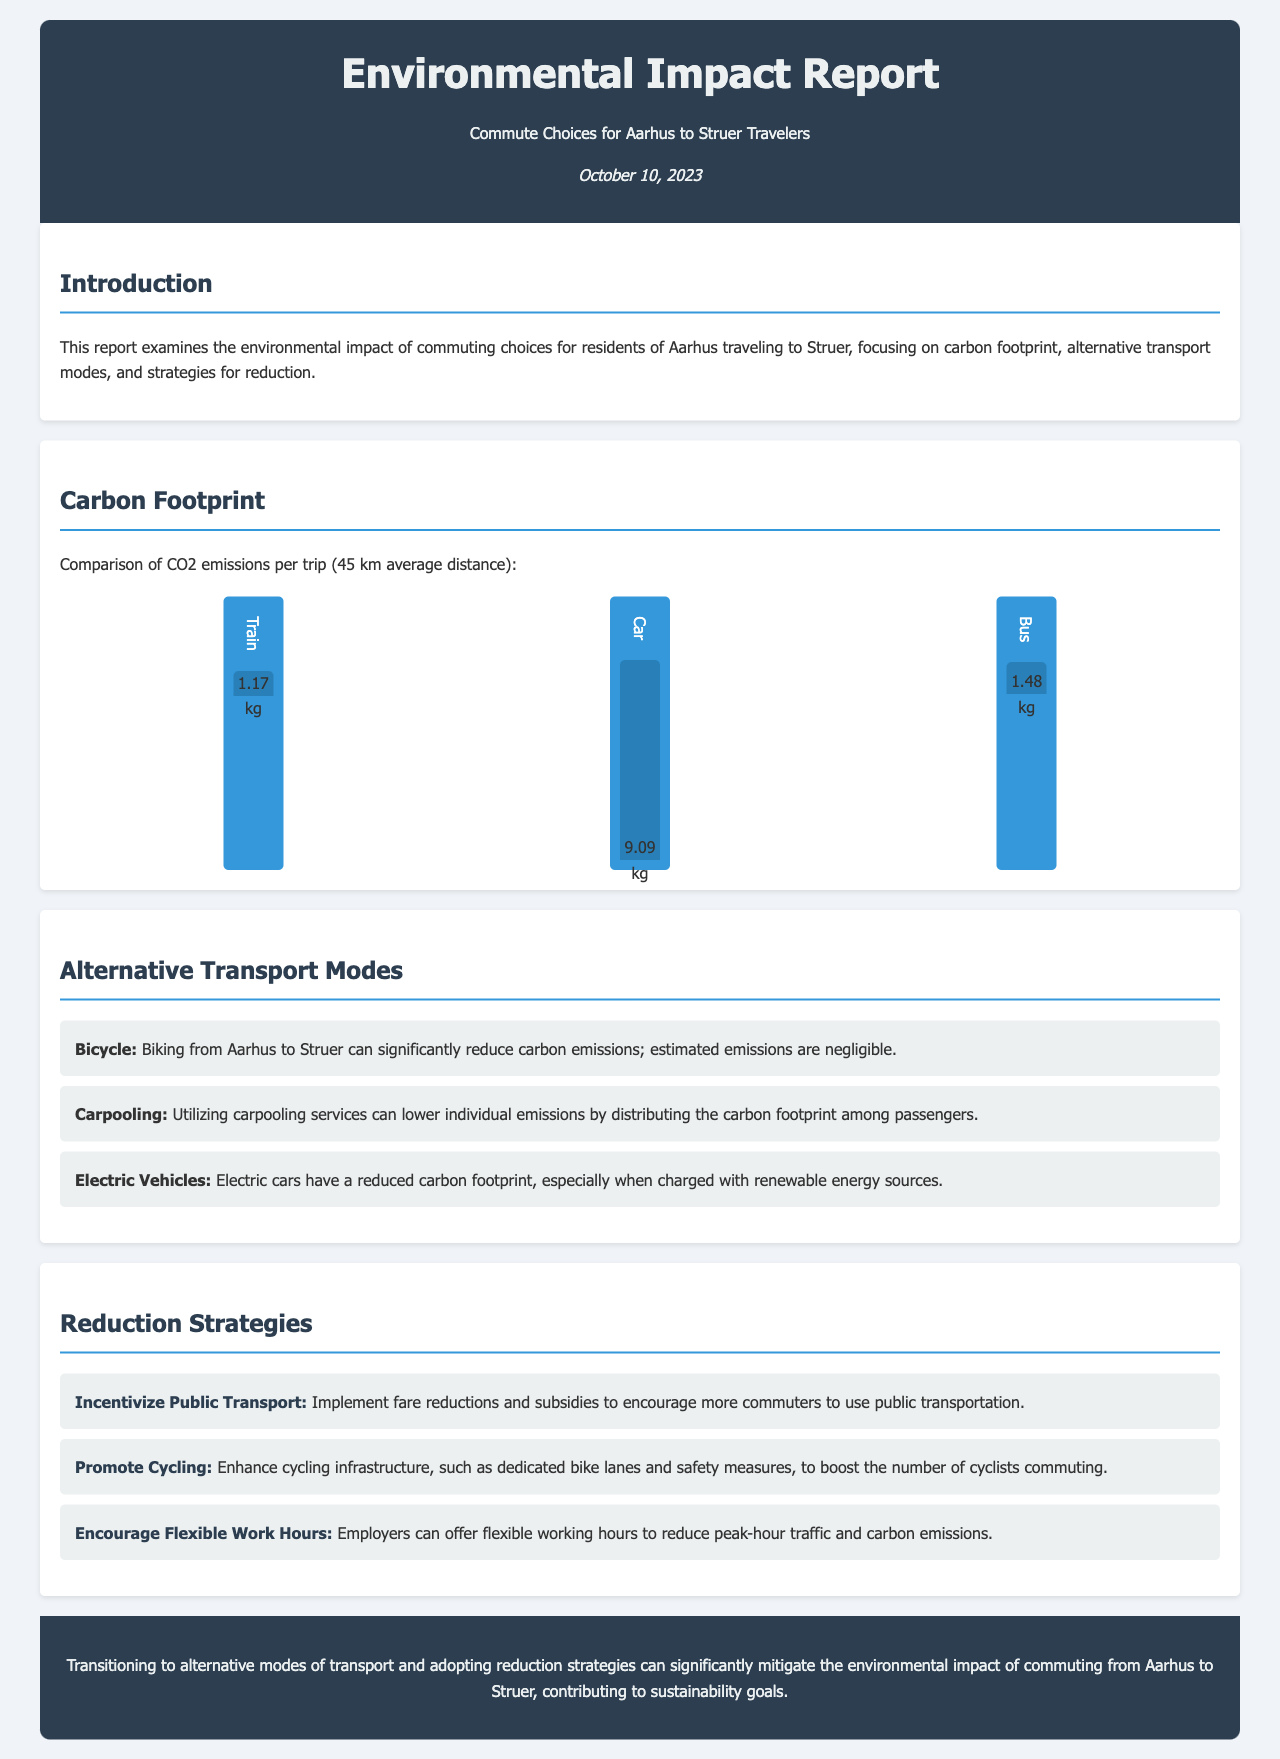What is the average distance of the commute? The average distance of the commute from Aarhus to Struer is stated as 45 km.
Answer: 45 km What is the carbon footprint of traveling by train? The document specifically lists the CO2 emissions per trip for the train as 1.17 kg.
Answer: 1.17 kg How much can car emissions be compared to train emissions? The report indicates that car emissions are significantly higher at 9.09 kg compared to train emissions of 1.17 kg.
Answer: 9.09 kg What alternative transport mode has negligible emissions? The report notes that biking from Aarhus to Struer results in negligible emissions.
Answer: Biking Which strategy encourages the use of public transportation? One of the reduction strategies mentioned focuses on incentivizing public transport through fare reductions and subsidies.
Answer: Incentivize Public Transport What is one benefit of carpooling according to the report? The report states that carpooling can lower individual emissions by distributing the carbon footprint among passengers.
Answer: Lower individual emissions How does the report suggest enhancing cycling? The document suggests promoting cycling by enhancing infrastructure such as dedicated bike lanes and safety measures.
Answer: Enhance cycling infrastructure What date was the report published? The publication date of the report is mentioned as October 10, 2023.
Answer: October 10, 2023 